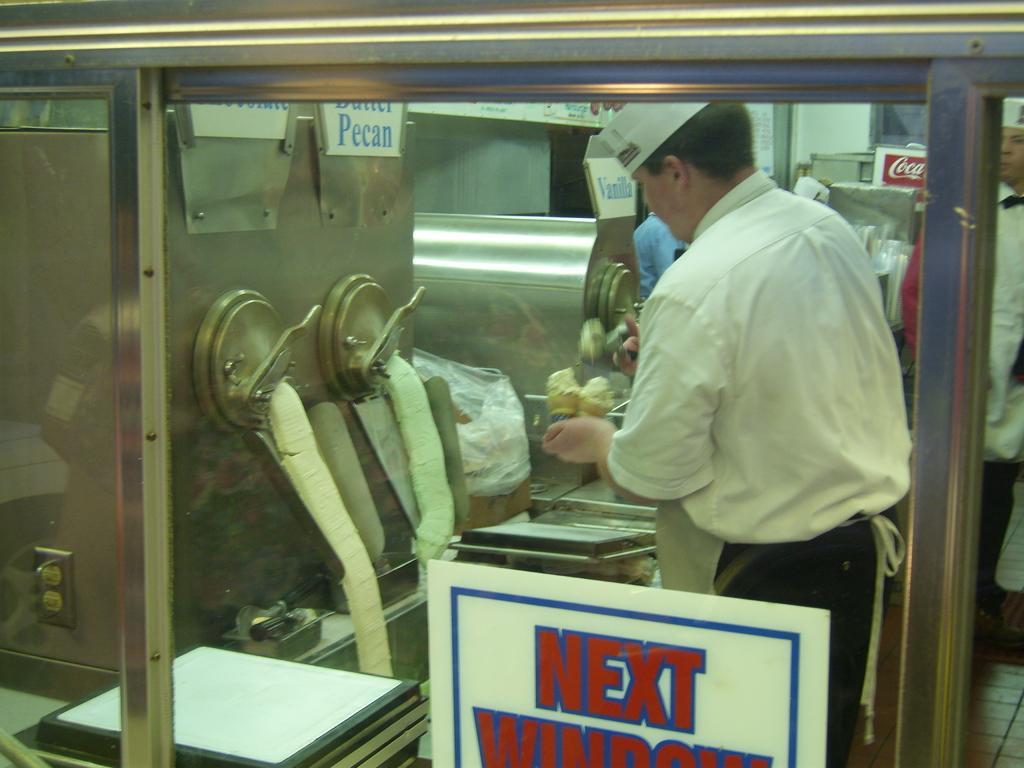Can you describe this image briefly? This is the man standing and preparing the ice creams. This looks like the ice cream machines. I think this is a poster, which is attached to the glass door. On the right side of the image, I can see another person standing. 